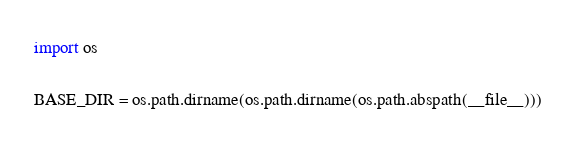Convert code to text. <code><loc_0><loc_0><loc_500><loc_500><_Python_>import os

BASE_DIR = os.path.dirname(os.path.dirname(os.path.abspath(__file__)))</code> 